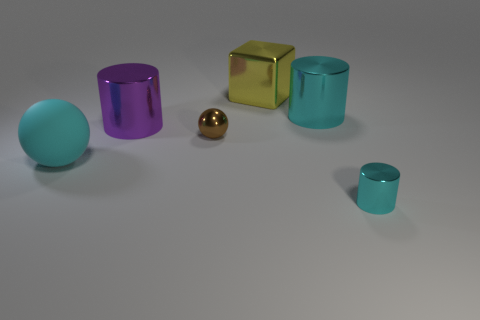There is a metallic thing that is the same color as the tiny cylinder; what shape is it?
Offer a terse response. Cylinder. There is a shiny cylinder behind the metallic cylinder to the left of the yellow object; what is its size?
Provide a succinct answer. Large. The object that is in front of the tiny brown metallic object and on the left side of the large yellow shiny block is made of what material?
Ensure brevity in your answer.  Rubber. Is there anything else that has the same shape as the yellow object?
Your response must be concise. No. Is the number of cubes that are to the left of the large purple thing the same as the number of purple blocks?
Offer a terse response. Yes. How many large metallic things are the same shape as the tiny cyan object?
Your answer should be very brief. 2. Does the big purple shiny object have the same shape as the tiny cyan shiny thing?
Your answer should be very brief. Yes. How many objects are cylinders on the left side of the small cylinder or yellow things?
Provide a succinct answer. 3. There is a large cyan thing to the left of the tiny metallic object that is on the left side of the small object right of the big yellow cube; what shape is it?
Offer a terse response. Sphere. There is a tiny cyan object that is the same material as the large yellow block; what shape is it?
Your answer should be very brief. Cylinder. 